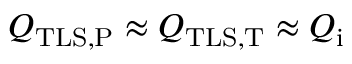<formula> <loc_0><loc_0><loc_500><loc_500>Q _ { T L S , P } \approx Q _ { T L S , T } \approx Q _ { i }</formula> 